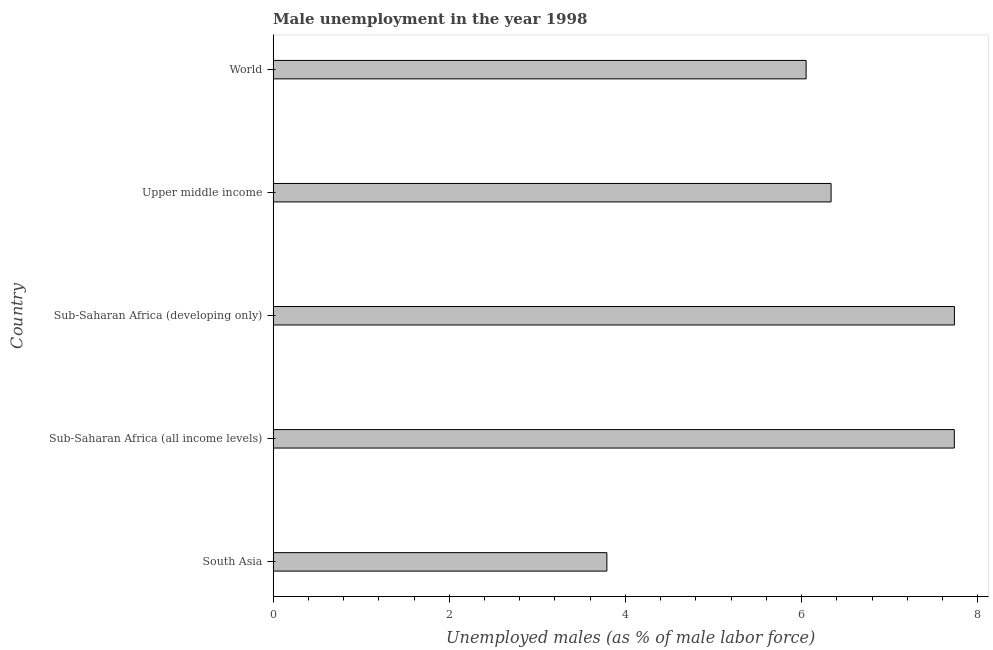Does the graph contain any zero values?
Your answer should be very brief. No. What is the title of the graph?
Give a very brief answer. Male unemployment in the year 1998. What is the label or title of the X-axis?
Your answer should be compact. Unemployed males (as % of male labor force). What is the label or title of the Y-axis?
Make the answer very short. Country. What is the unemployed males population in World?
Give a very brief answer. 6.05. Across all countries, what is the maximum unemployed males population?
Offer a terse response. 7.74. Across all countries, what is the minimum unemployed males population?
Give a very brief answer. 3.79. In which country was the unemployed males population maximum?
Offer a very short reply. Sub-Saharan Africa (developing only). In which country was the unemployed males population minimum?
Offer a terse response. South Asia. What is the sum of the unemployed males population?
Provide a succinct answer. 31.64. What is the difference between the unemployed males population in Sub-Saharan Africa (all income levels) and World?
Offer a terse response. 1.68. What is the average unemployed males population per country?
Your answer should be compact. 6.33. What is the median unemployed males population?
Your answer should be very brief. 6.33. In how many countries, is the unemployed males population greater than 2.4 %?
Your answer should be compact. 5. What is the ratio of the unemployed males population in Sub-Saharan Africa (developing only) to that in Upper middle income?
Your answer should be compact. 1.22. Is the unemployed males population in South Asia less than that in World?
Offer a terse response. Yes. Is the difference between the unemployed males population in South Asia and Sub-Saharan Africa (developing only) greater than the difference between any two countries?
Ensure brevity in your answer.  Yes. What is the difference between the highest and the second highest unemployed males population?
Provide a succinct answer. 0. What is the difference between the highest and the lowest unemployed males population?
Keep it short and to the point. 3.95. How many bars are there?
Your answer should be compact. 5. How many countries are there in the graph?
Your response must be concise. 5. What is the difference between two consecutive major ticks on the X-axis?
Keep it short and to the point. 2. Are the values on the major ticks of X-axis written in scientific E-notation?
Ensure brevity in your answer.  No. What is the Unemployed males (as % of male labor force) of South Asia?
Keep it short and to the point. 3.79. What is the Unemployed males (as % of male labor force) of Sub-Saharan Africa (all income levels)?
Offer a terse response. 7.73. What is the Unemployed males (as % of male labor force) in Sub-Saharan Africa (developing only)?
Keep it short and to the point. 7.74. What is the Unemployed males (as % of male labor force) in Upper middle income?
Your answer should be compact. 6.33. What is the Unemployed males (as % of male labor force) of World?
Give a very brief answer. 6.05. What is the difference between the Unemployed males (as % of male labor force) in South Asia and Sub-Saharan Africa (all income levels)?
Keep it short and to the point. -3.94. What is the difference between the Unemployed males (as % of male labor force) in South Asia and Sub-Saharan Africa (developing only)?
Provide a short and direct response. -3.95. What is the difference between the Unemployed males (as % of male labor force) in South Asia and Upper middle income?
Offer a terse response. -2.55. What is the difference between the Unemployed males (as % of male labor force) in South Asia and World?
Offer a very short reply. -2.26. What is the difference between the Unemployed males (as % of male labor force) in Sub-Saharan Africa (all income levels) and Sub-Saharan Africa (developing only)?
Your answer should be compact. -0. What is the difference between the Unemployed males (as % of male labor force) in Sub-Saharan Africa (all income levels) and Upper middle income?
Provide a short and direct response. 1.4. What is the difference between the Unemployed males (as % of male labor force) in Sub-Saharan Africa (all income levels) and World?
Provide a short and direct response. 1.68. What is the difference between the Unemployed males (as % of male labor force) in Sub-Saharan Africa (developing only) and Upper middle income?
Your response must be concise. 1.4. What is the difference between the Unemployed males (as % of male labor force) in Sub-Saharan Africa (developing only) and World?
Make the answer very short. 1.68. What is the difference between the Unemployed males (as % of male labor force) in Upper middle income and World?
Keep it short and to the point. 0.28. What is the ratio of the Unemployed males (as % of male labor force) in South Asia to that in Sub-Saharan Africa (all income levels)?
Provide a short and direct response. 0.49. What is the ratio of the Unemployed males (as % of male labor force) in South Asia to that in Sub-Saharan Africa (developing only)?
Keep it short and to the point. 0.49. What is the ratio of the Unemployed males (as % of male labor force) in South Asia to that in Upper middle income?
Give a very brief answer. 0.6. What is the ratio of the Unemployed males (as % of male labor force) in South Asia to that in World?
Your answer should be very brief. 0.63. What is the ratio of the Unemployed males (as % of male labor force) in Sub-Saharan Africa (all income levels) to that in Sub-Saharan Africa (developing only)?
Ensure brevity in your answer.  1. What is the ratio of the Unemployed males (as % of male labor force) in Sub-Saharan Africa (all income levels) to that in Upper middle income?
Offer a very short reply. 1.22. What is the ratio of the Unemployed males (as % of male labor force) in Sub-Saharan Africa (all income levels) to that in World?
Provide a short and direct response. 1.28. What is the ratio of the Unemployed males (as % of male labor force) in Sub-Saharan Africa (developing only) to that in Upper middle income?
Keep it short and to the point. 1.22. What is the ratio of the Unemployed males (as % of male labor force) in Sub-Saharan Africa (developing only) to that in World?
Keep it short and to the point. 1.28. What is the ratio of the Unemployed males (as % of male labor force) in Upper middle income to that in World?
Your response must be concise. 1.05. 